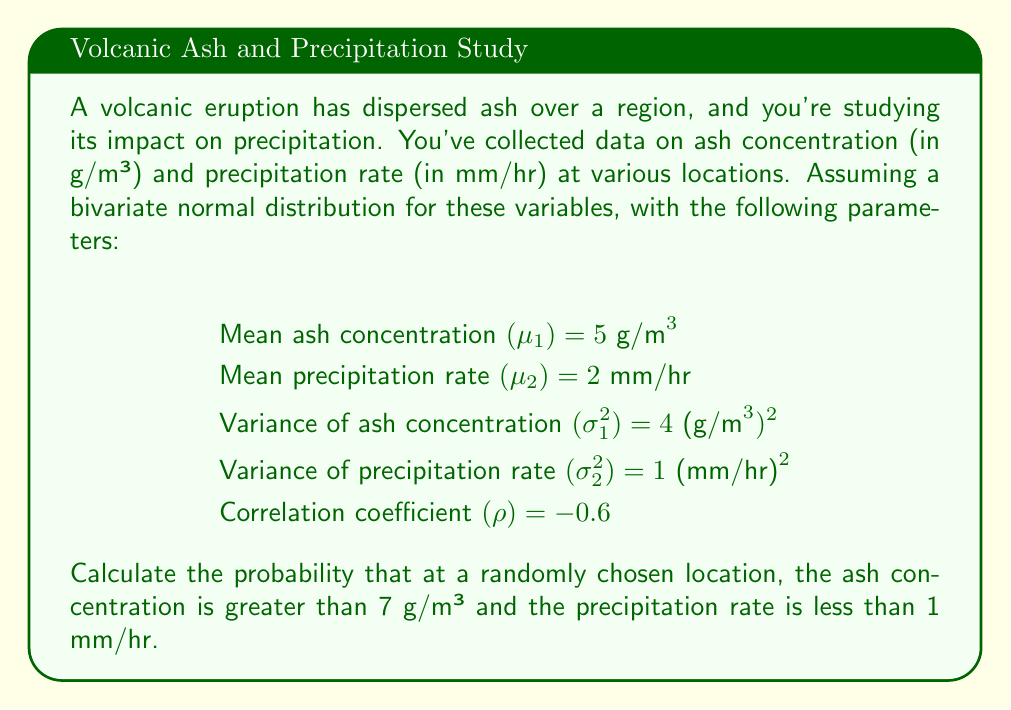Solve this math problem. To solve this problem, we'll use the properties of the bivariate normal distribution and follow these steps:

1) First, we need to standardize our variables. Let X be the ash concentration and Y be the precipitation rate. The standardized variables are:

   $$Z_1 = \frac{X - \mu_1}{\sigma_1} = \frac{X - 5}{2}$$
   $$Z_2 = \frac{Y - \mu_2}{\sigma_2} = \frac{Y - 2}{1}$$

2) Our problem asks for P(X > 7, Y < 1), which in terms of Z₁ and Z₂ is:

   $$P(Z_1 > 1, Z_2 < -1)$$

3) For a bivariate normal distribution, we can express this as:

   $$P(Z_1 > 1, Z_2 < -1) = P(Z_1 > 1) - P(Z_1 > 1, Z_2 > -1)$$

4) P(Z₁ > 1) can be found using a standard normal table:

   $$P(Z_1 > 1) = 1 - \Phi(1) \approx 0.1587$$

5) For P(Z₁ > 1, Z₂ > -1), we need to use the bivariate normal distribution function. This involves a complex integral, but it can be approximated using numerical methods or specialized tables. The result depends on the correlation coefficient ρ.

6) Using a bivariate normal calculator or table with ρ = -0.6, we find:

   $$P(Z_1 > 1, Z_2 > -1) \approx 0.0207$$

7) Therefore, our final result is:

   $$P(X > 7, Y < 1) = P(Z_1 > 1) - P(Z_1 > 1, Z_2 > -1)$$
   $$\approx 0.1587 - 0.0207 = 0.1380$$

Thus, the probability is approximately 0.1380 or 13.80%.
Answer: 0.1380 